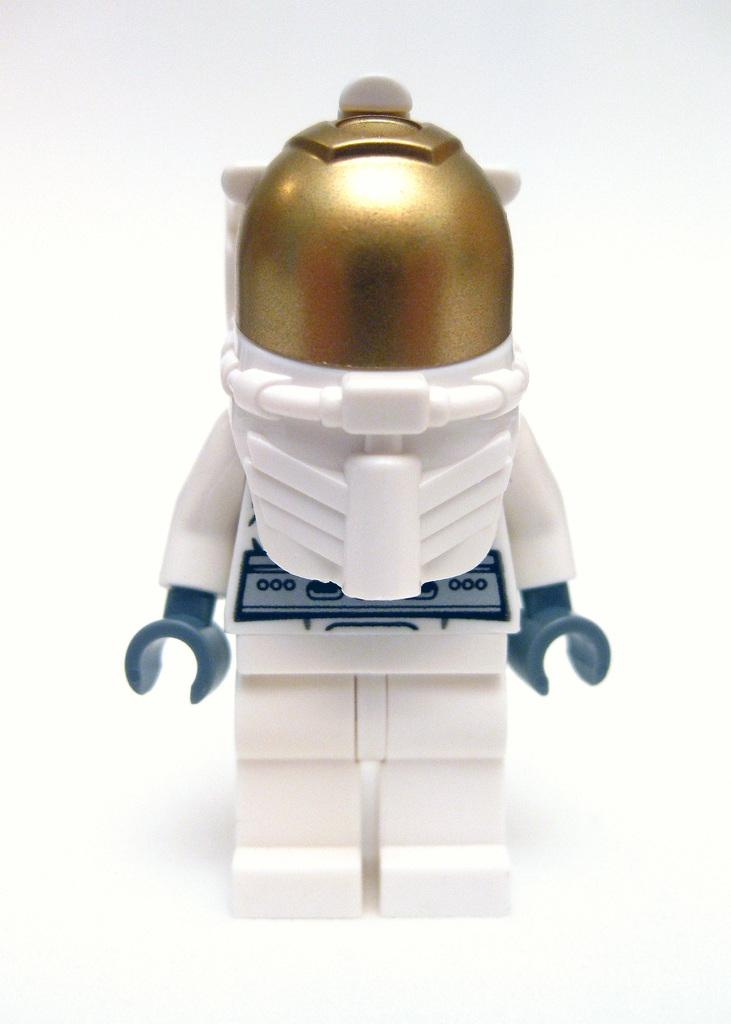What is the main subject in the center of the image? There is a lego in the center of the image. What type of thread is being used by the friends in the image? There are no friends or thread present in the image; it only features a lego. 